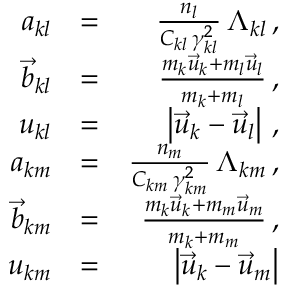Convert formula to latex. <formula><loc_0><loc_0><loc_500><loc_500>\begin{array} { r l r } { a _ { k l } } & { = } & { \frac { n _ { l } } { C _ { k l } \, \gamma _ { k l } ^ { 2 } } \, \Lambda _ { k l } \, , } \\ { \vec { b } _ { k l } } & { = } & { \frac { m _ { k } \vec { u } _ { k } + m _ { l } \vec { u } _ { l } } { m _ { k } + m _ { l } } \, , } \\ { u _ { k l } } & { = } & { \left | \vec { u } _ { k } - \vec { u } _ { l } \right | \, , } \\ { a _ { k m } } & { = } & { \frac { n _ { m } } { C _ { k m } \, \gamma _ { k m } ^ { 2 } } \, \Lambda _ { k m } \, , } \\ { \vec { b } _ { k m } } & { = } & { \frac { m _ { k } \vec { u } _ { k } + m _ { m } \vec { u } _ { m } } { m _ { k } + m _ { m } } \, , } \\ { u _ { k m } } & { = } & { \left | \vec { u } _ { k } - \vec { u } _ { m } \right | } \end{array}</formula> 